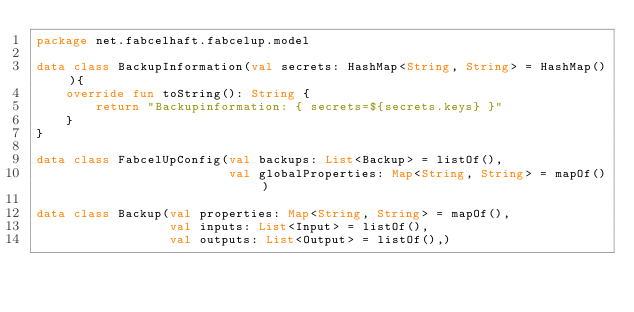<code> <loc_0><loc_0><loc_500><loc_500><_Kotlin_>package net.fabcelhaft.fabcelup.model

data class BackupInformation(val secrets: HashMap<String, String> = HashMap()){
    override fun toString(): String {
        return "Backupinformation: { secrets=${secrets.keys} }"
    }
}

data class FabcelUpConfig(val backups: List<Backup> = listOf(),
                          val globalProperties: Map<String, String> = mapOf())

data class Backup(val properties: Map<String, String> = mapOf(),
                  val inputs: List<Input> = listOf(),
                  val outputs: List<Output> = listOf(),)
</code> 